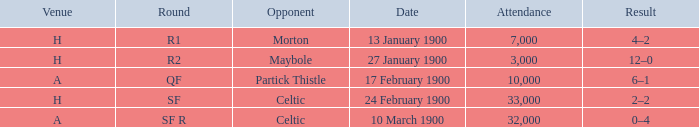Who played against in venue a on 17 february 1900? Partick Thistle. 